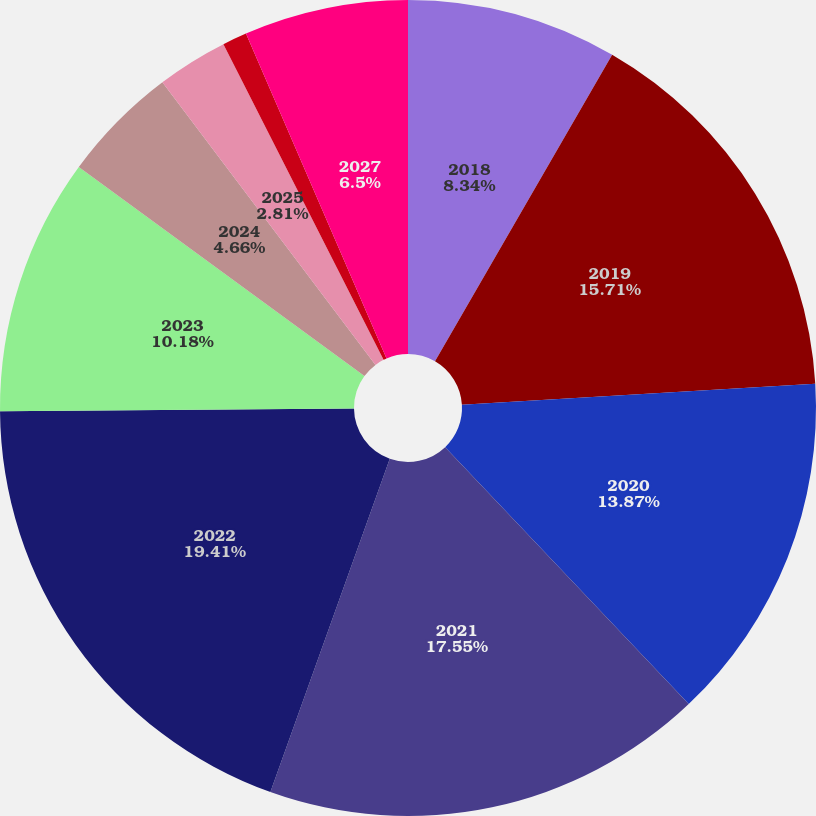Convert chart to OTSL. <chart><loc_0><loc_0><loc_500><loc_500><pie_chart><fcel>2018<fcel>2019<fcel>2020<fcel>2021<fcel>2022<fcel>2023<fcel>2024<fcel>2025<fcel>2026<fcel>2027<nl><fcel>8.34%<fcel>15.71%<fcel>13.87%<fcel>17.55%<fcel>19.4%<fcel>10.18%<fcel>4.66%<fcel>2.81%<fcel>0.97%<fcel>6.5%<nl></chart> 